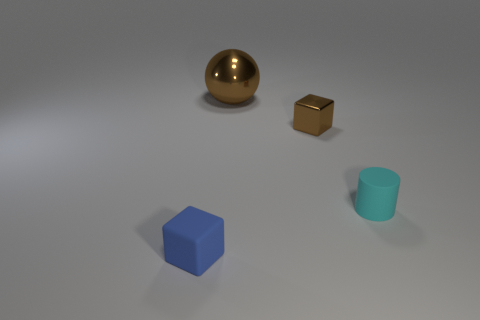How many objects have the same color as the large shiny sphere?
Provide a succinct answer. 1. What material is the cyan cylinder that is the same size as the matte cube?
Keep it short and to the point. Rubber. How many large shiny balls are there?
Your answer should be very brief. 1. There is a cube that is behind the small cyan rubber object; how big is it?
Offer a very short reply. Small. Are there an equal number of rubber objects right of the blue block and blue matte things?
Your answer should be very brief. Yes. Are there any blue rubber things that have the same shape as the tiny cyan object?
Ensure brevity in your answer.  No. There is a object that is to the right of the big shiny object and left of the cylinder; what is its shape?
Provide a succinct answer. Cube. Is the material of the big brown thing the same as the object that is in front of the cyan thing?
Ensure brevity in your answer.  No. There is a cyan rubber cylinder; are there any tiny brown metallic objects in front of it?
Offer a terse response. No. What number of things are either large things or things that are right of the blue matte cube?
Make the answer very short. 3. 